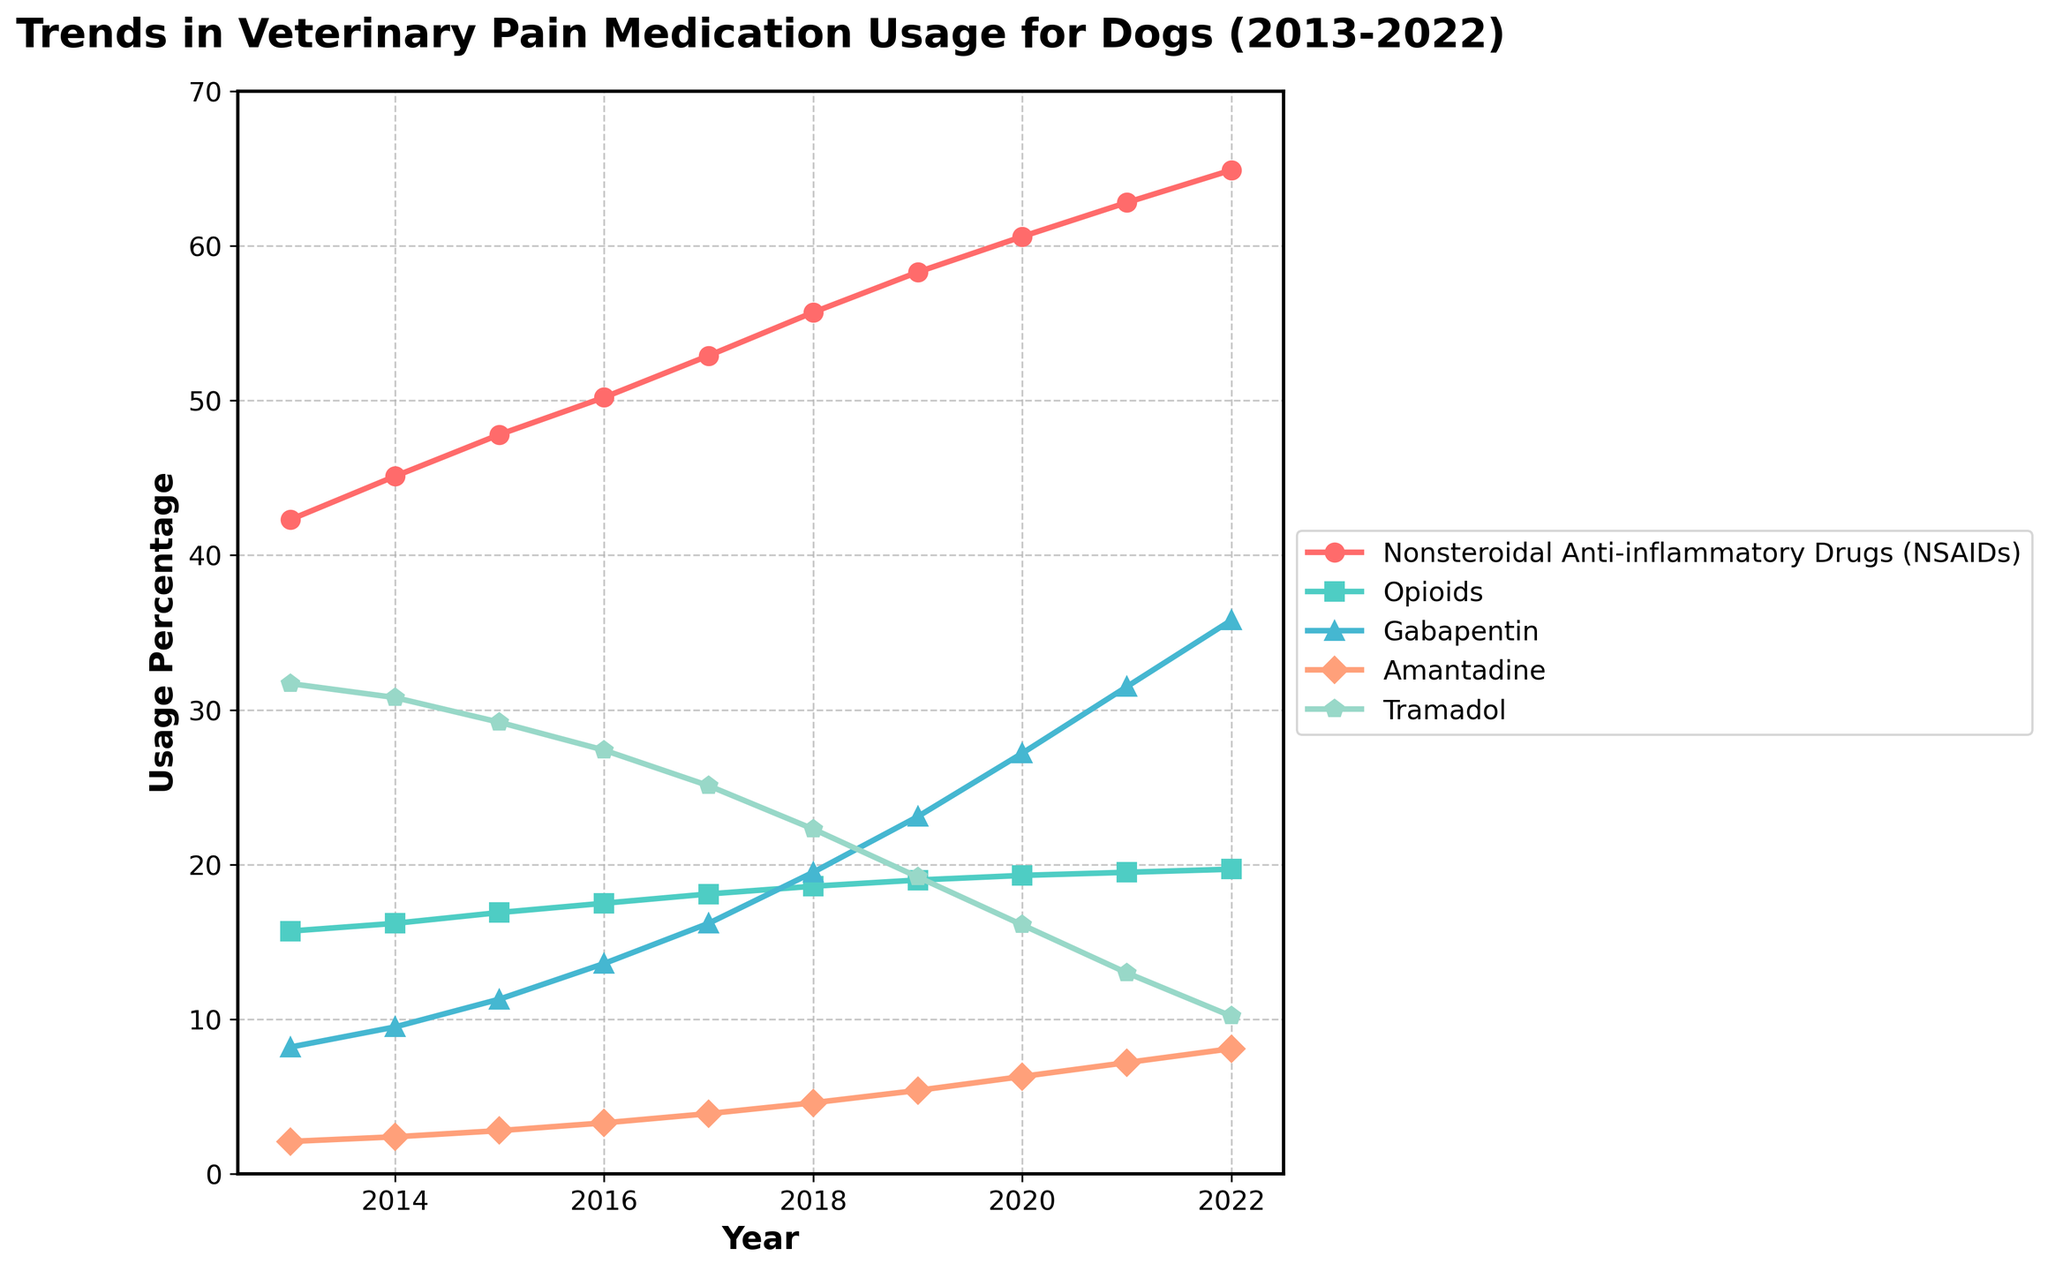What is the overall trend in the usage of Nonsteroidal Anti-inflammatory Drugs (NSAIDs) from 2013 to 2022? To determine the trend, observe the line representing NSAIDs usage across the years and note how the line moves from left to right. The line generally moves upward, indicating an increase.
Answer: Increasing Which medication type had the highest increase in usage percentage from 2013 to 2022? Calculate the difference in usage percentages between 2013 and 2022 for each medication type. NSAIDs increased from 42.3% to 64.9%, Opioids from 15.7% to 19.7%, Gabapentin from 8.2% to 35.8%, Amantadine from 2.1% to 8.1%, and Tramadol from 31.7% to 10.2%. Gabapentin had the highest increase (35.8% - 8.2% = 27.6%).
Answer: Gabapentin In 2020, which medication had nearly the same usage percentage as Gabapentin in 2016? From the 2020 data, Gabapentin had a usage percentage of 27.2%. Looking at the 2016 data, Gabapentin had a usage percentage of 13.6%. Therefore, none of the other medications in 2016 closely matched 27.2%.
Answer: None Between which consecutive years did Tramadol see the largest decrease in usage percentage? Compare the year-over-year decreases for Tramadol. The differences are: 
2013-2014: 31.7% - 30.8% = 0.9%, 
2014-2015: 30.8% - 29.2% = 1.6%, 
2015-2016: 29.2% - 27.4% = 1.8%, 
2016-2017: 27.4% - 25.1% = 2.3%, 
2017-2018: 25.1% - 22.3% = 2.8%, 
2018-2019: 22.3% - 19.2% = 3.1%, 
2019-2020: 19.2% - 16.1% = 3.1%, 
2020-2021: 16.1% - 13.0% = 3.1%, 
2021-2022: 13.0% - 10.2% = 2.8%. 
The largest decrease is between 2018-2019, 2019-2020, and 2020-2021 with a 3.1% decrease.
Answer: 2018-2021 What is the approximate average yearly usage percentage of Amantadine for the period 2013-2022? Sum the yearly usage percentages for Amantadine over the decade and divide by the number of years: (2.1 + 2.4 + 2.8 + 3.3 + 3.9 + 4.6 + 5.4 + 6.3 + 7.2 + 8.1) = 46.1. Divide by 10, the number of years: 46.1 / 10 = 4.61%.
Answer: Approximately 4.61% Which medication was the least used in 2017? Find the lowest usage percentage in the 2017 data. NSAIDs: 52.9%, Opioids: 18.1%, Gabapentin: 16.2%, Amantadine: 3.9%, Tramadol: 25.1%. Amantadine has the lowest percentage.
Answer: Amantadine By how much did the usage of Opioids change from 2013 to 2022? Subtract the Opioids usage percentage in 2013 from that in 2022: 19.7% - 15.7% = 4.0%.
Answer: 4.0% What is the difference between the highest and lowest yearly usage percentages of Gabapentin over the decade? Identify the highest (35.8% in 2022) and lowest (8.2% in 2013) values for Gabapentin, then subtract the latter from the former: 35.8% - 8.2% = 27.6%.
Answer: 27.6% In which year did Nonsteroidal Anti-inflammatory Drugs (NSAIDs) surpass 50% usage? Check the data for NSAIDs and identify the first year where the percentage exceeds 50%. This occurs in 2016 with a usage of 50.2%.
Answer: 2016 